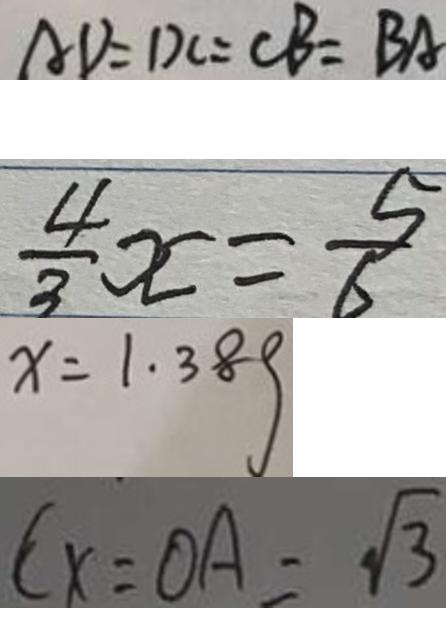Convert formula to latex. <formula><loc_0><loc_0><loc_500><loc_500>A D = D C = C B = B A 
 \frac { 4 } { 3 } x = \frac { 5 } { 6 } 
 x = 1 . 3 8 g 
 C x = O A = \sqrt { 3 }</formula> 